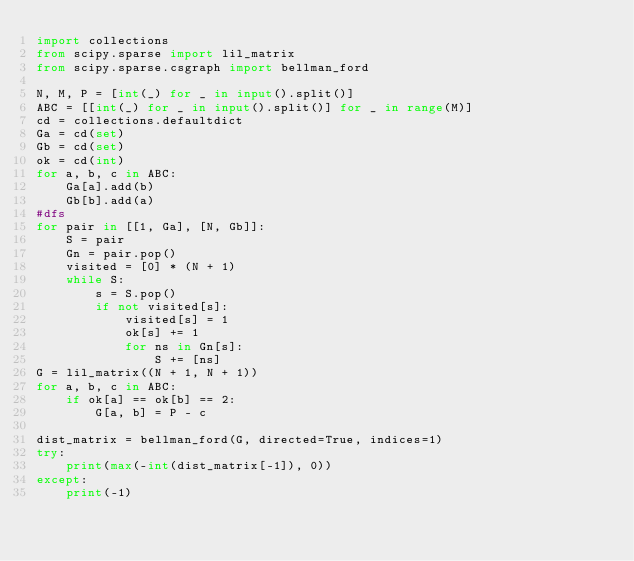<code> <loc_0><loc_0><loc_500><loc_500><_Python_>import collections
from scipy.sparse import lil_matrix
from scipy.sparse.csgraph import bellman_ford

N, M, P = [int(_) for _ in input().split()]
ABC = [[int(_) for _ in input().split()] for _ in range(M)]
cd = collections.defaultdict
Ga = cd(set)
Gb = cd(set)
ok = cd(int)
for a, b, c in ABC:
    Ga[a].add(b)
    Gb[b].add(a)
#dfs
for pair in [[1, Ga], [N, Gb]]:
    S = pair
    Gn = pair.pop()
    visited = [0] * (N + 1)
    while S:
        s = S.pop()
        if not visited[s]:
            visited[s] = 1
            ok[s] += 1
            for ns in Gn[s]:
                S += [ns]
G = lil_matrix((N + 1, N + 1))
for a, b, c in ABC:
    if ok[a] == ok[b] == 2:
        G[a, b] = P - c

dist_matrix = bellman_ford(G, directed=True, indices=1)
try:
    print(max(-int(dist_matrix[-1]), 0))
except:
    print(-1)
</code> 